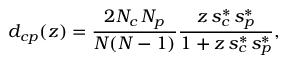Convert formula to latex. <formula><loc_0><loc_0><loc_500><loc_500>d _ { c p } ( z ) = \frac { 2 N _ { c } \, N _ { p } } { N ( N - 1 ) } \frac { z \, s _ { c } ^ { * } \, s _ { p } ^ { * } } { 1 + z \, s _ { c } ^ { * } \, s _ { p } ^ { * } } ,</formula> 